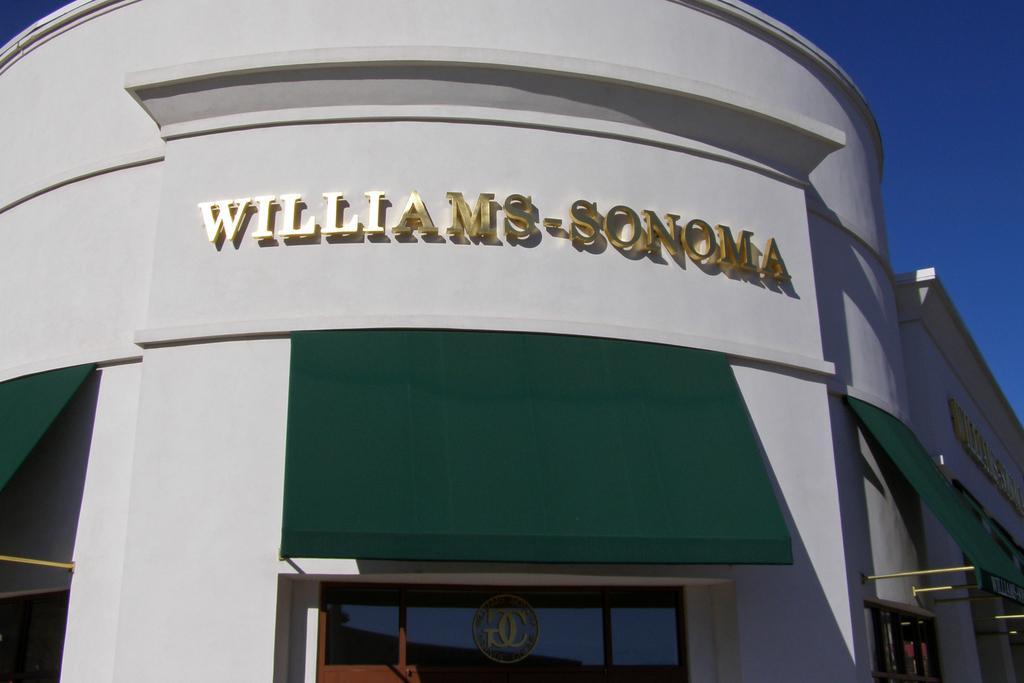Please provide a concise description of this image. In this picture, we see a building in white and green color. At the bottom, we see a window. On the right side, we see the windows. In the middle of the picture, we see some text written as "WILLIAMS SONOMA". In the right top, we see the sky, which is blue in color. 